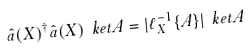<formula> <loc_0><loc_0><loc_500><loc_500>\hat { a } ( X ) ^ { \dagger } \hat { a } ( X ) \ k e t { A } = | \ell _ { X } ^ { - 1 } \{ A \} | \ k e t { A }</formula> 